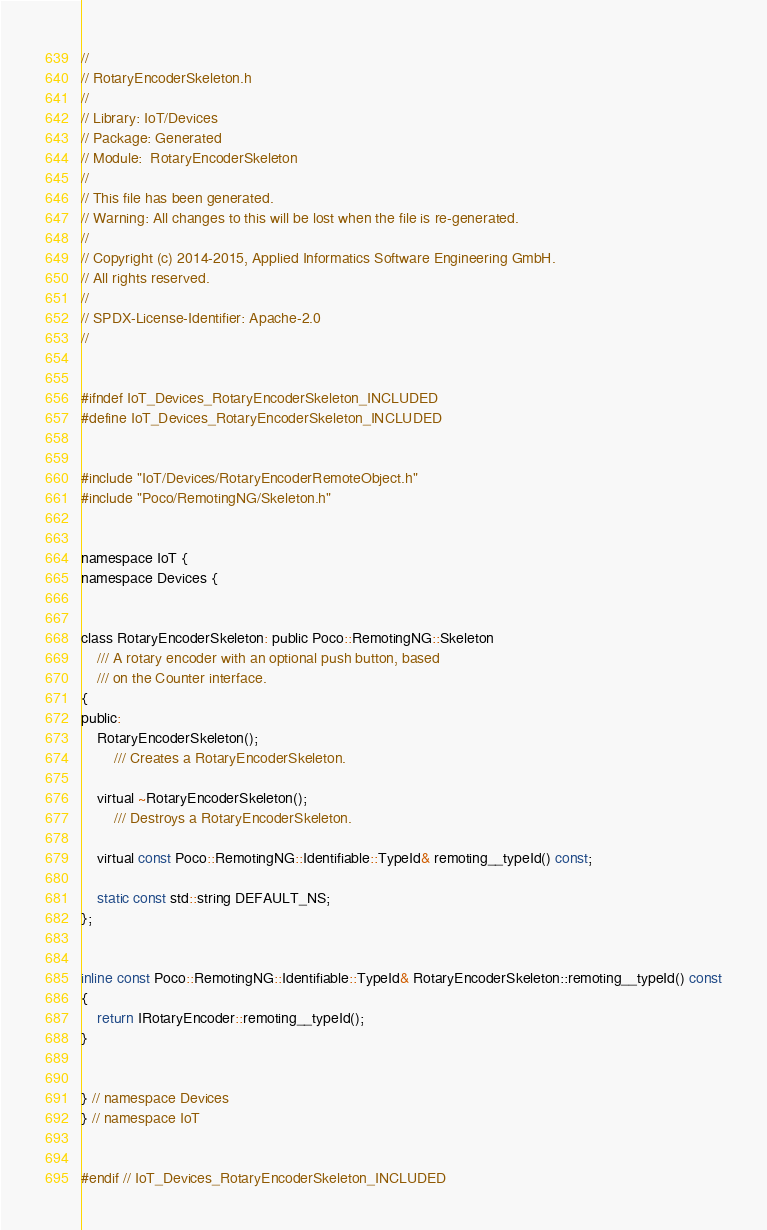Convert code to text. <code><loc_0><loc_0><loc_500><loc_500><_C_>//
// RotaryEncoderSkeleton.h
//
// Library: IoT/Devices
// Package: Generated
// Module:  RotaryEncoderSkeleton
//
// This file has been generated.
// Warning: All changes to this will be lost when the file is re-generated.
//
// Copyright (c) 2014-2015, Applied Informatics Software Engineering GmbH.
// All rights reserved.
// 
// SPDX-License-Identifier: Apache-2.0
//


#ifndef IoT_Devices_RotaryEncoderSkeleton_INCLUDED
#define IoT_Devices_RotaryEncoderSkeleton_INCLUDED


#include "IoT/Devices/RotaryEncoderRemoteObject.h"
#include "Poco/RemotingNG/Skeleton.h"


namespace IoT {
namespace Devices {


class RotaryEncoderSkeleton: public Poco::RemotingNG::Skeleton
	/// A rotary encoder with an optional push button, based
	/// on the Counter interface.
{
public:
	RotaryEncoderSkeleton();
		/// Creates a RotaryEncoderSkeleton.

	virtual ~RotaryEncoderSkeleton();
		/// Destroys a RotaryEncoderSkeleton.

	virtual const Poco::RemotingNG::Identifiable::TypeId& remoting__typeId() const;

	static const std::string DEFAULT_NS;
};


inline const Poco::RemotingNG::Identifiable::TypeId& RotaryEncoderSkeleton::remoting__typeId() const
{
	return IRotaryEncoder::remoting__typeId();
}


} // namespace Devices
} // namespace IoT


#endif // IoT_Devices_RotaryEncoderSkeleton_INCLUDED

</code> 